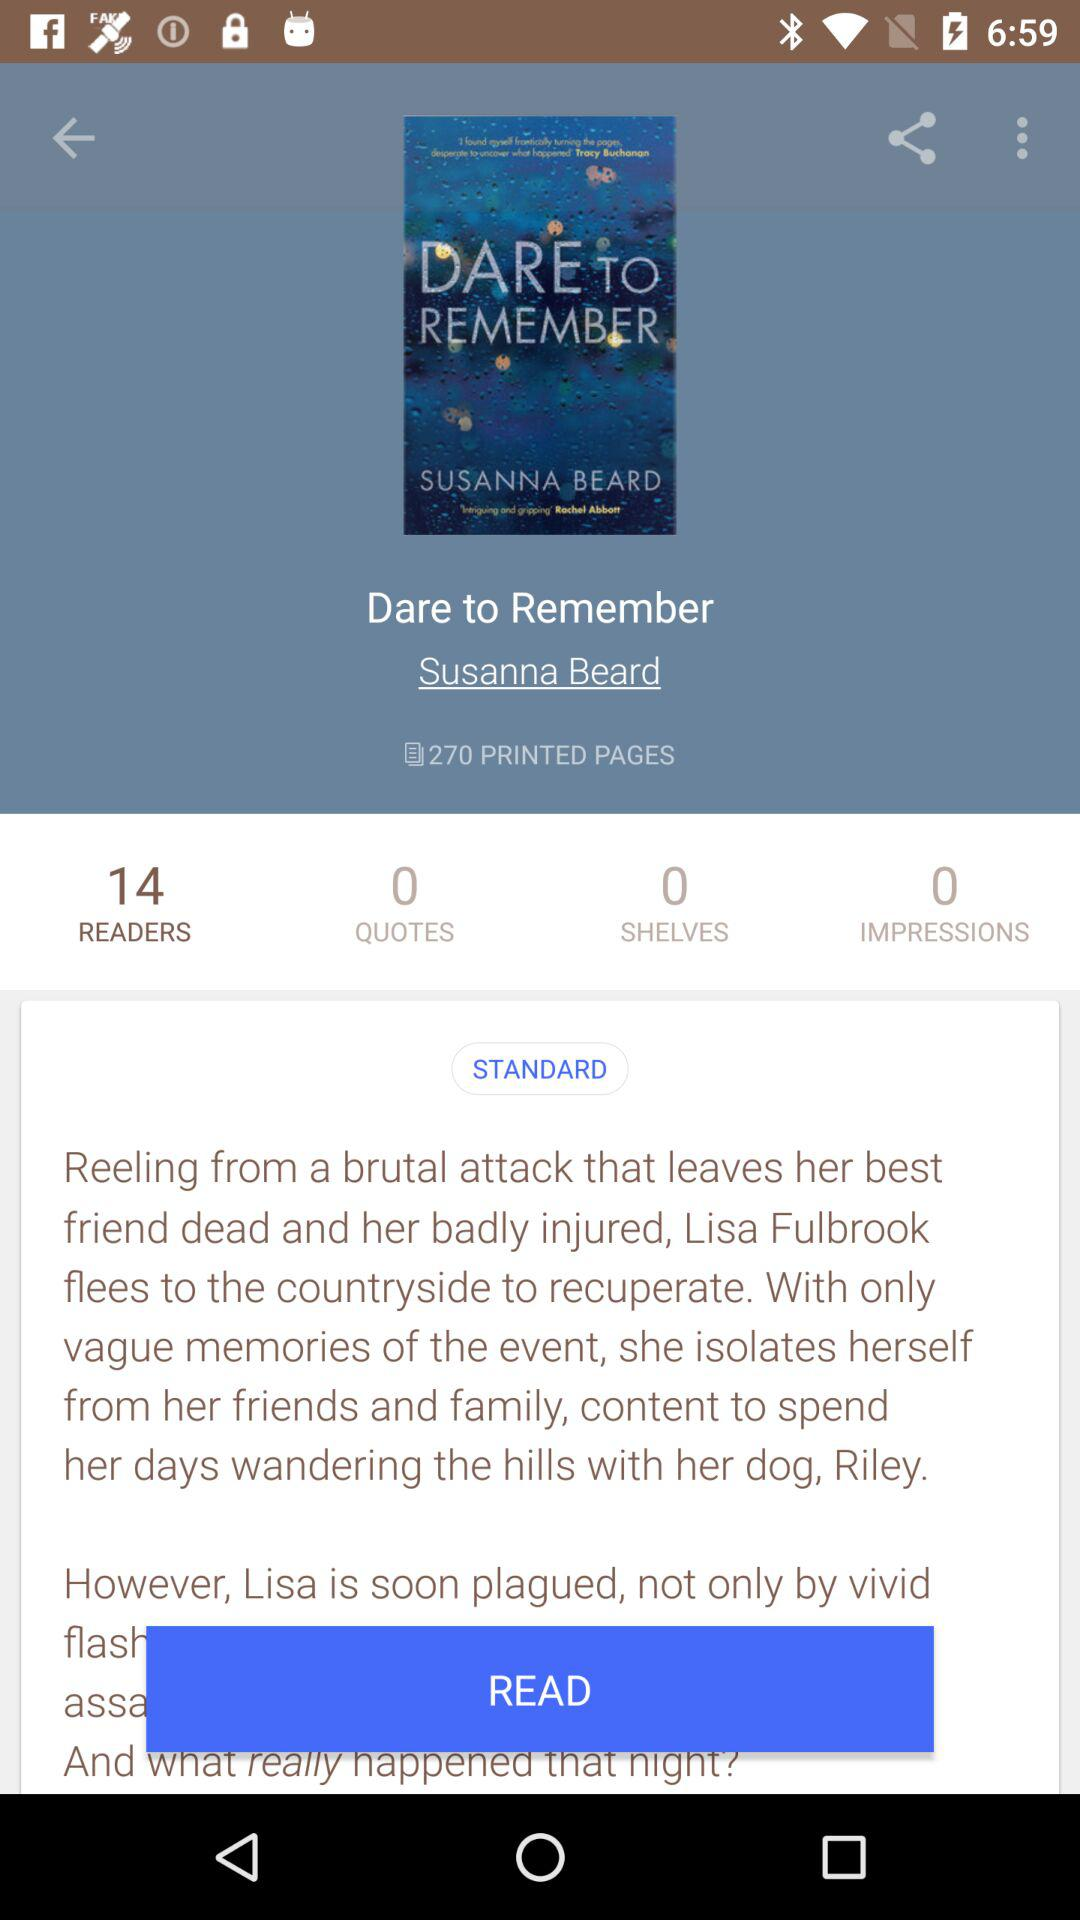How many pages does the book contain? The book contains 270 pages. 